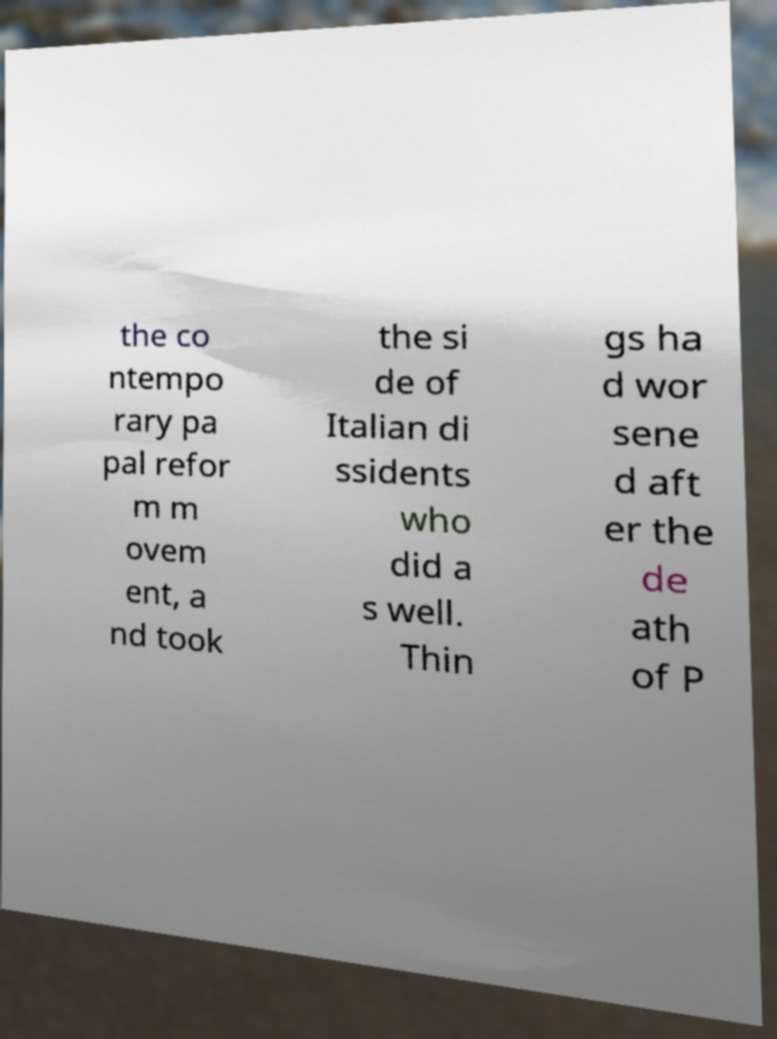Please read and relay the text visible in this image. What does it say? the co ntempo rary pa pal refor m m ovem ent, a nd took the si de of Italian di ssidents who did a s well. Thin gs ha d wor sene d aft er the de ath of P 